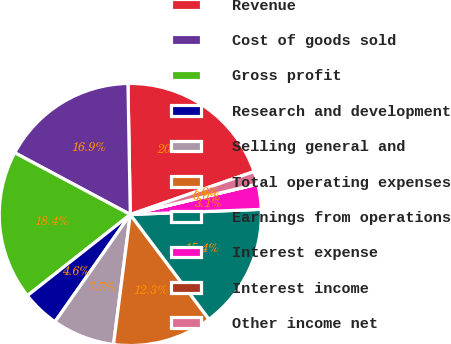Convert chart to OTSL. <chart><loc_0><loc_0><loc_500><loc_500><pie_chart><fcel>Revenue<fcel>Cost of goods sold<fcel>Gross profit<fcel>Research and development<fcel>Selling general and<fcel>Total operating expenses<fcel>Earnings from operations<fcel>Interest expense<fcel>Interest income<fcel>Other income net<nl><fcel>19.97%<fcel>16.9%<fcel>18.44%<fcel>4.63%<fcel>7.7%<fcel>12.3%<fcel>15.37%<fcel>3.1%<fcel>0.03%<fcel>1.56%<nl></chart> 